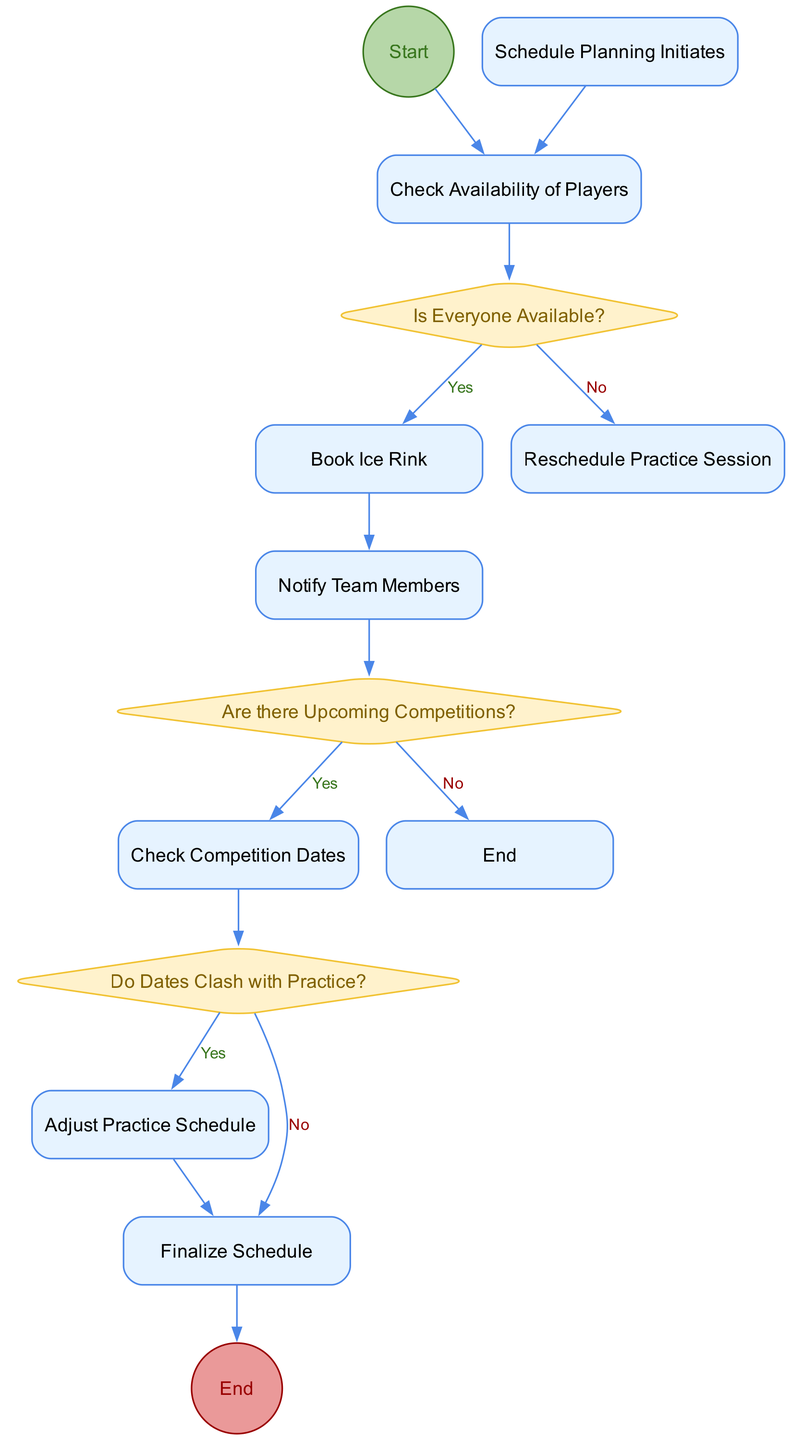What is the starting point of the diagram? The diagram starts with the "Schedule Planning Initiates" node. The initial node labeled "Start" directs the flow towards the first activity, which is to check the availability of players.
Answer: Schedule Planning Initiates How many decision nodes are in the diagram? The diagram contains three decision nodes. These decision nodes are "Is Everyone Available?", "Are there Upcoming Competitions?", and "Do Dates Clash with Practice?".
Answer: 3 What do you do if everyone is not available? If not everyone is available, the process directs to "Reschedule Practice Session". This is the branch that is taken if the answer to the decision "Is Everyone Available?" is "No".
Answer: Reschedule Practice Session What happens after checking If there are upcoming competitions? After checking if there are upcoming competitions and if the answer is "Yes", the next activity is "Check Competition Dates". This continues the flow towards determining how to adjust practice schedules accordingly.
Answer: Check Competition Dates What is the last activity before the diagram ends? The last activity before reaching the end of the diagram is "Finalize Schedule". After adjusting the schedule for any clashes, the next step is to finalize it before concluding the diagram with an "End" node.
Answer: Finalize Schedule If competition dates clash with practice, what is the next step? If there is a clash between competition dates and practice schedules, the next step is to "Adjust Practice Schedule". This means that adjustments need to be made to ensure both practices and competitions can be attended.
Answer: Adjust Practice Schedule What is the color of the start node? The start node is color-coded with a fill color of light green (#B6D7A8) representing the start of the process. This green color distinguishes it as the initiation point for the activity diagram.
Answer: Light green In the diagram, how do you proceed after confirming everyone is available? Once everyone is confirmed to be available, the flow continues to the "Book Ice Rink" activity. This signifies that a venue is being secured for practice, allowing the team to train together.
Answer: Book Ice Rink 